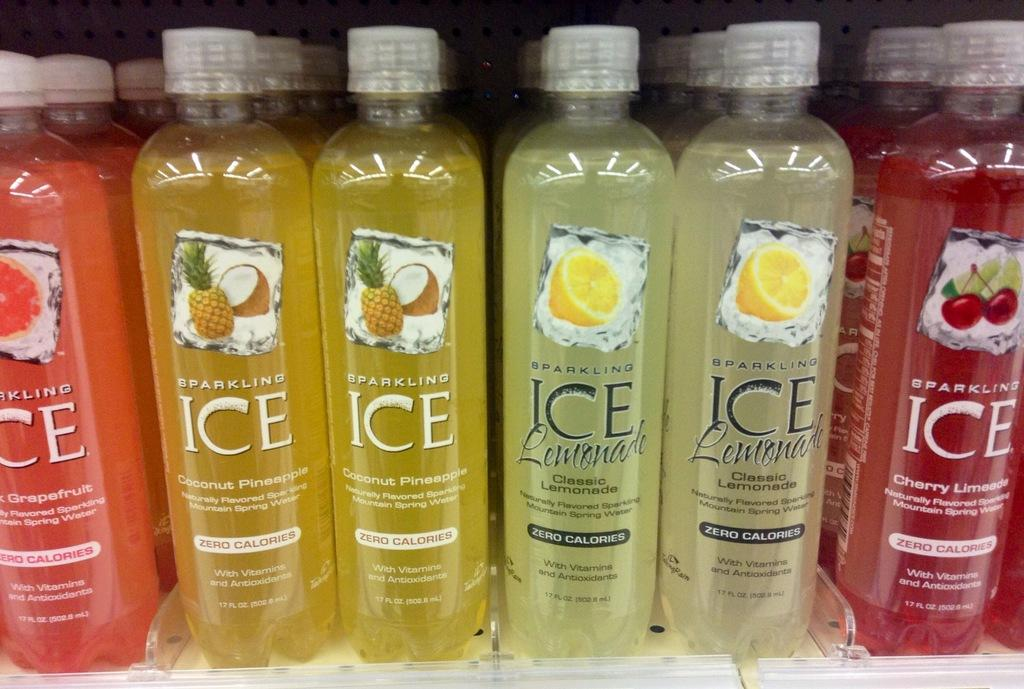Provide a one-sentence caption for the provided image. several containers of sparkling ice liquids in many colors. 